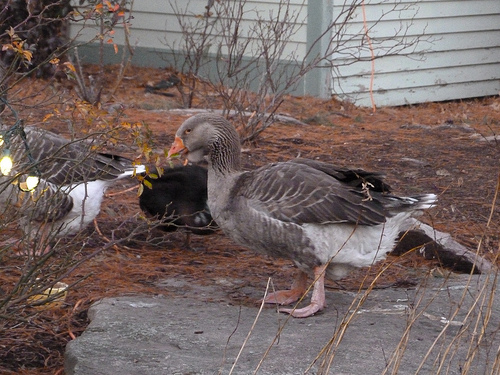<image>
Can you confirm if the bird is to the left of the house? No. The bird is not to the left of the house. From this viewpoint, they have a different horizontal relationship. 